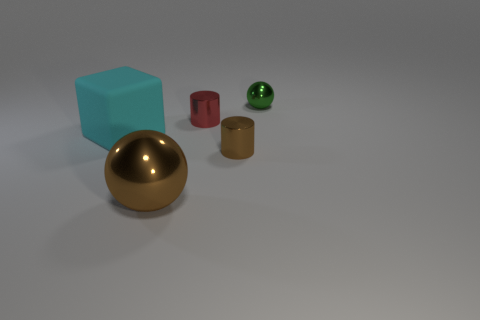Add 2 small green shiny spheres. How many objects exist? 7 Subtract all cylinders. How many objects are left? 3 Subtract 0 red balls. How many objects are left? 5 Subtract all large brown matte objects. Subtract all big objects. How many objects are left? 3 Add 5 tiny brown metal cylinders. How many tiny brown metal cylinders are left? 6 Add 5 tiny brown metal cylinders. How many tiny brown metal cylinders exist? 6 